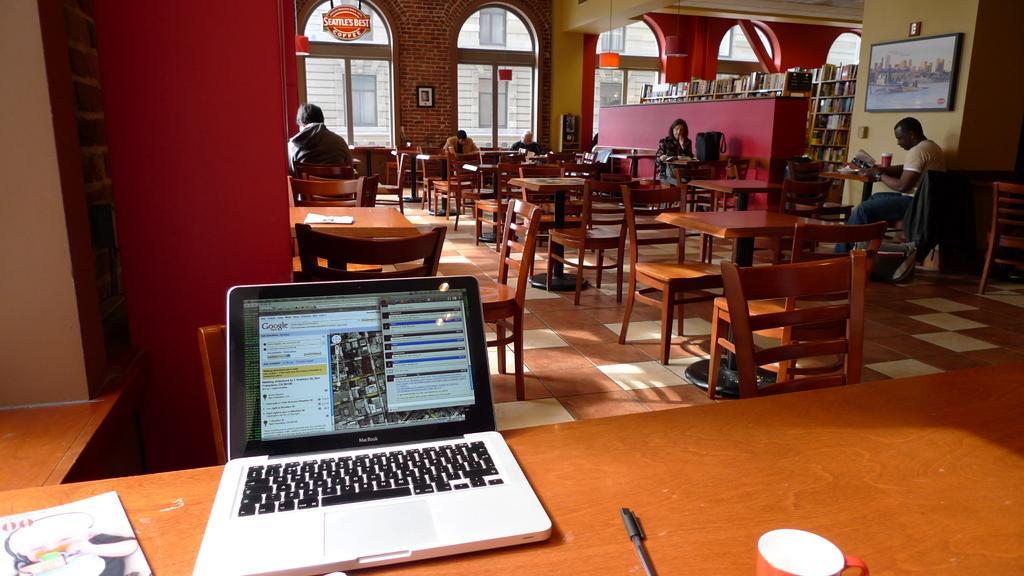Please provide a concise description of this image. As we can see in the image there are windows, wall, tables, chairs and few people sitting here and there. In the front there is a table. On table is a book, laptop, pen and cup. 